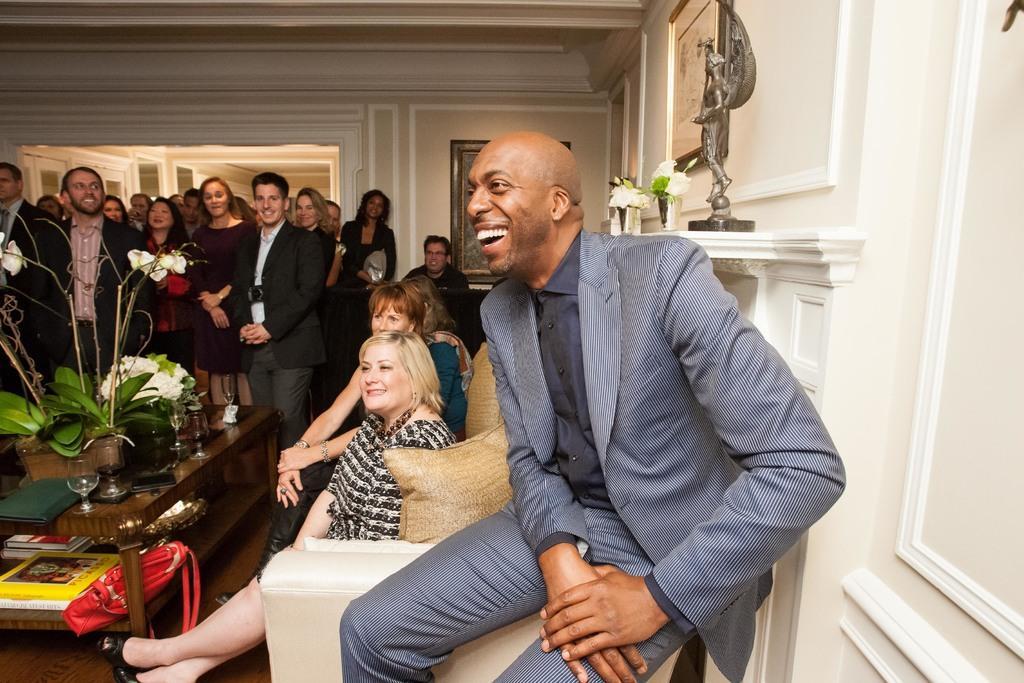How would you summarize this image in a sentence or two? In the foreground of the picture we can see a person in grey suit, he is laughing. In the center of the picture there are flower cases, couch, pillows, bag, books, sculpture, frame, wall and people. Towards left there are group of people. In the background we can see doors, frame and wall. 